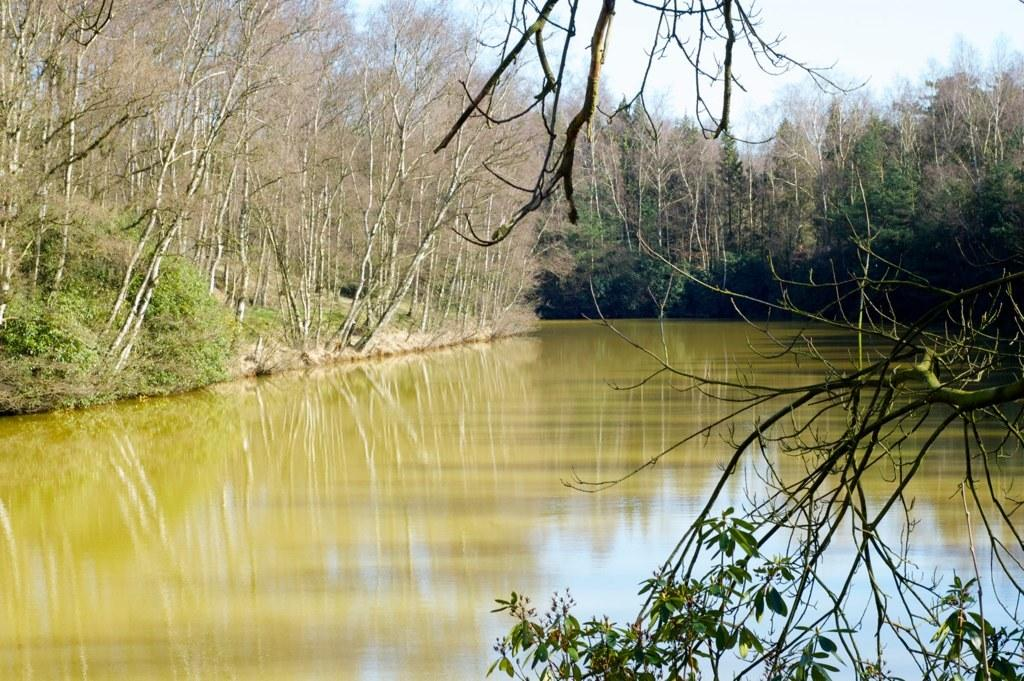What is the main element in the picture? There is water in the picture. What is the color of the water? The water is green in color. What type of vegetation is present around the water? There are plants and trees around the water. What can be seen in the background of the picture? The sky is visible in the background of the picture. What is the degree of the hole in the water in the image? There is no hole present in the water in the image. 